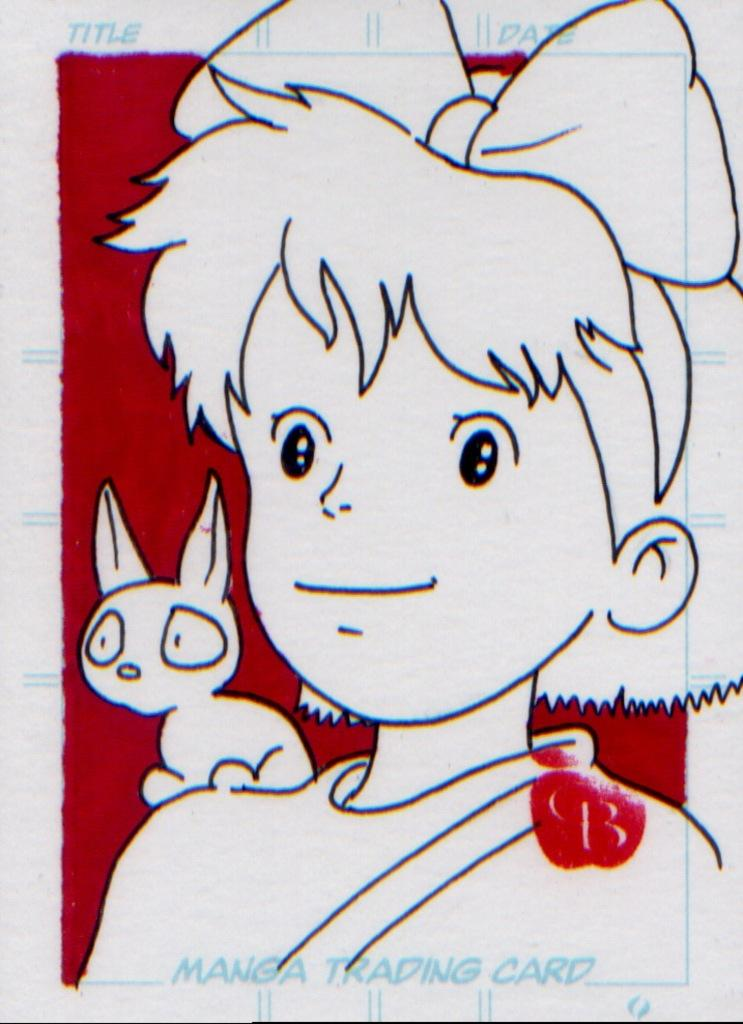What is depicted on the paper in the image? There is a sketch on the paper. Are there any colors used in the sketch? Some parts of the sketch are covered with red color. How many snails can be seen crawling on the sketch in the image? There are no snails present in the image; the sketch is the main focus. What type of joke is being told in the image? There is no joke being told in the image; it features a sketch with red color. 